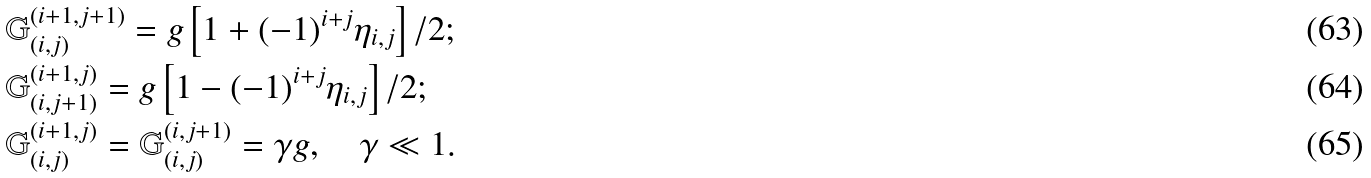<formula> <loc_0><loc_0><loc_500><loc_500>& { \mathbb { G } } _ { ( i , j ) } ^ { ( i + 1 , j + 1 ) } = { g } \left [ 1 + ( - 1 ) ^ { i + j } \eta _ { i , j } \right ] / 2 ; \\ & { \mathbb { G } } _ { ( i , j + 1 ) } ^ { ( i + 1 , j ) } = { g } \left [ 1 - ( - 1 ) ^ { i + j } \eta _ { i , j } \right ] / 2 ; \\ & { \mathbb { G } } _ { ( i , j ) } ^ { ( i + 1 , j ) } = { \mathbb { G } } _ { ( i , j ) } ^ { ( i , j + 1 ) } = \gamma g , \quad \gamma \ll 1 .</formula> 